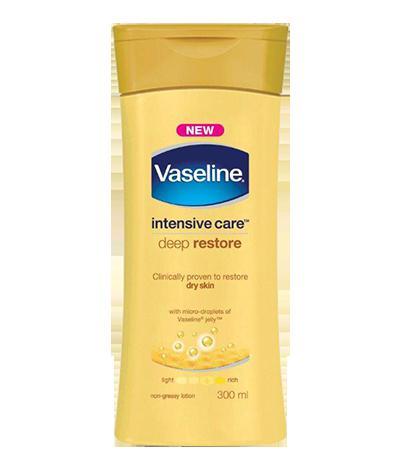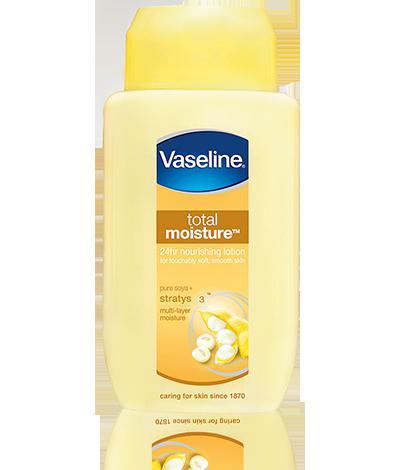The first image is the image on the left, the second image is the image on the right. Examine the images to the left and right. Is the description "Lotions are in groups of three with flip-top lids." accurate? Answer yes or no. No. 